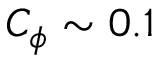<formula> <loc_0><loc_0><loc_500><loc_500>C _ { \phi } \sim 0 . 1</formula> 